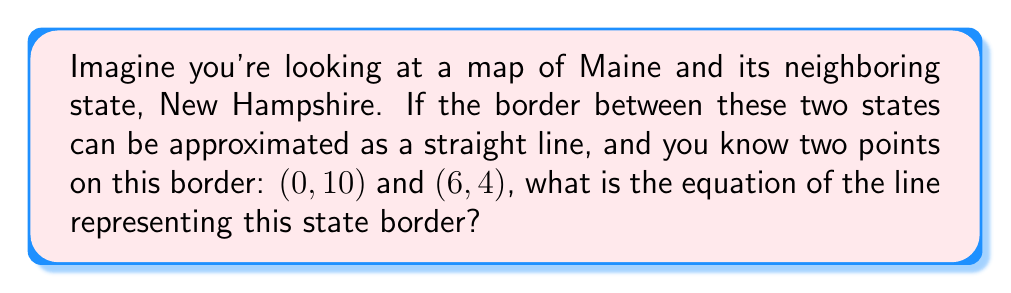Show me your answer to this math problem. Let's approach this step-by-step:

1) To find the equation of a line, we can use the point-slope form: $y - y_1 = m(x - x_1)$, where $m$ is the slope of the line.

2) We need to calculate the slope first. The slope formula is:

   $m = \frac{y_2 - y_1}{x_2 - x_1}$

3) Using the given points (0, 10) and (6, 4):

   $m = \frac{4 - 10}{6 - 0} = \frac{-6}{6} = -1$

4) Now that we have the slope, we can use either point to write the equation. Let's use (0, 10):

   $y - 10 = -1(x - 0)$

5) Simplify:

   $y - 10 = -x$

6) Add 10 to both sides:

   $y = -x + 10$

This is the equation of the line in slope-intercept form $(y = mx + b)$, where $m = -1$ and $b = 10$.
Answer: $y = -x + 10$ 